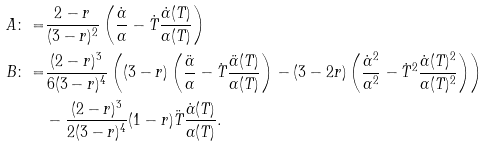<formula> <loc_0><loc_0><loc_500><loc_500>A \colon = & \frac { 2 - r } { ( 3 - r ) ^ { 2 } } \left ( \frac { \dot { \alpha } } { \alpha } - \dot { T } \frac { \dot { \alpha } ( T ) } { \alpha ( T ) } \right ) \\ B \colon = & \frac { ( 2 - r ) ^ { 3 } } { 6 ( 3 - r ) ^ { 4 } } \left ( ( 3 - r ) \left ( \frac { \ddot { \alpha } } { \alpha } - \dot { T } \frac { \ddot { \alpha } ( T ) } { \alpha ( T ) } \right ) - ( 3 - 2 r ) \left ( \frac { \dot { \alpha } ^ { 2 } } { \alpha ^ { 2 } } - \dot { T } ^ { 2 } \frac { \dot { \alpha } ( T ) ^ { 2 } } { \alpha ( T ) ^ { 2 } } \right ) \right ) \\ & - \frac { ( 2 - r ) ^ { 3 } } { 2 ( 3 - r ) ^ { 4 } } ( 1 - r ) \ddot { T } \frac { \dot { \alpha } ( T ) } { \alpha ( T ) } .</formula> 